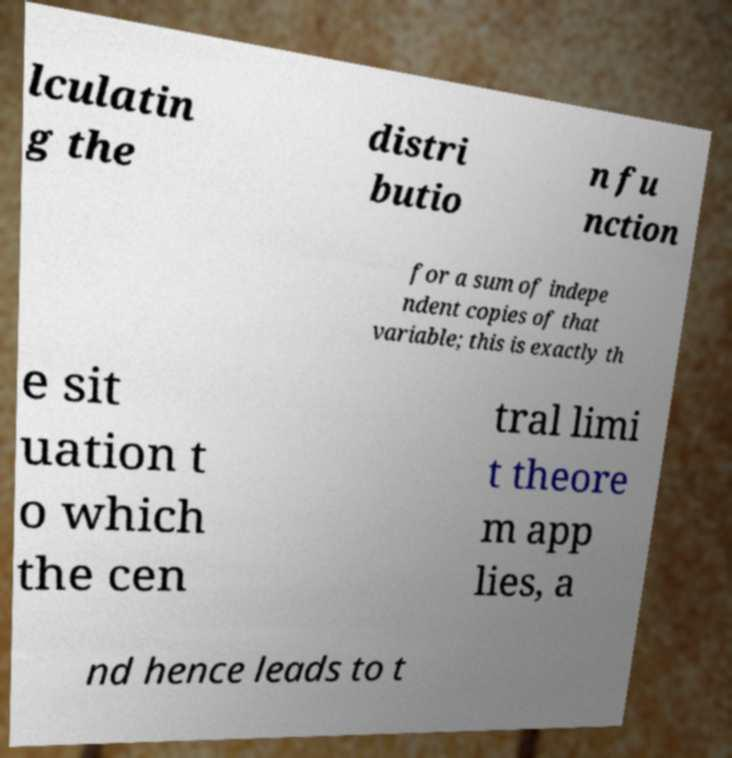For documentation purposes, I need the text within this image transcribed. Could you provide that? lculatin g the distri butio n fu nction for a sum of indepe ndent copies of that variable; this is exactly th e sit uation t o which the cen tral limi t theore m app lies, a nd hence leads to t 